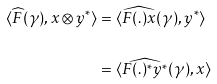Convert formula to latex. <formula><loc_0><loc_0><loc_500><loc_500>\langle \widehat { F } ( \gamma ) , x \otimes y ^ { * } \rangle & = \langle \widehat { F ( . ) x } ( \gamma ) , y ^ { * } \rangle \\ & = \langle \widehat { F ( . ) ^ { * } y ^ { * } } ( \gamma ) , x \rangle</formula> 